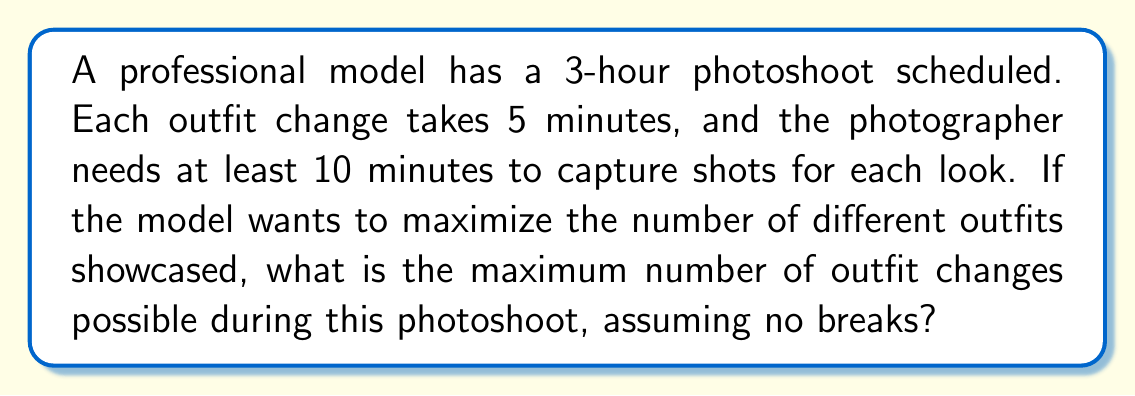Can you answer this question? Let's approach this step-by-step:

1) First, let's convert the total photoshoot time to minutes:
   3 hours = 3 × 60 = 180 minutes

2) Let $x$ be the number of outfit changes. We need to set up an inequality:

   $$(5x + 10x) \leq 180$$

   Here, $5x$ represents the total time spent changing outfits, and $10x$ represents the minimum time needed for photography.

3) Simplify the left side of the inequality:

   $$15x \leq 180$$

4) Divide both sides by 15:

   $$x \leq 12$$

5) Since $x$ represents the number of outfit changes, it must be a whole number. Therefore, the maximum value for $x$ is 12.

6) Let's verify:
   12 outfit changes: 12 × 5 = 60 minutes for changing
   12 looks photographed: 12 × 10 = 120 minutes for shooting
   Total: 60 + 120 = 180 minutes

This confirms that 12 is indeed the maximum number of outfit changes possible within the given constraints.
Answer: 12 